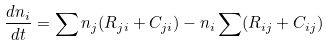Convert formula to latex. <formula><loc_0><loc_0><loc_500><loc_500>\frac { d n _ { i } } { d t } = \sum n _ { j } ( R _ { j i } + C _ { j i } ) - n _ { i } \sum ( R _ { i j } + C _ { i j } )</formula> 